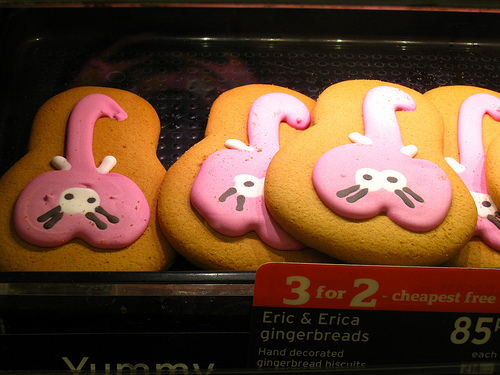<image>
Can you confirm if the cookies is behind the cookie? No. The cookies is not behind the cookie. From this viewpoint, the cookies appears to be positioned elsewhere in the scene. 